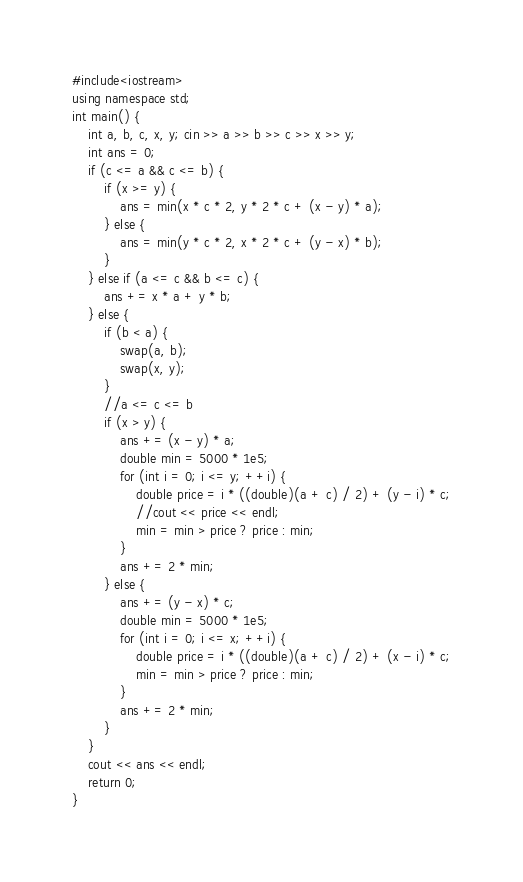<code> <loc_0><loc_0><loc_500><loc_500><_C++_>#include<iostream>
using namespace std;
int main() {
    int a, b, c, x, y; cin >> a >> b >> c >> x >> y;
    int ans = 0;
    if (c <= a && c <= b) {
        if (x >= y) {
            ans = min(x * c * 2, y * 2 * c + (x - y) * a);
        } else {
            ans = min(y * c * 2, x * 2 * c + (y - x) * b);
        }
    } else if (a <= c && b <= c) {
        ans += x * a + y * b;
    } else {
        if (b < a) {
            swap(a, b);
            swap(x, y);
        }
        //a <= c <= b
        if (x > y) {
            ans += (x - y) * a;
            double min = 5000 * 1e5;
            for (int i = 0; i <= y; ++i) {
                double price = i * ((double)(a + c) / 2) + (y - i) * c;
                //cout << price << endl;
                min = min > price ? price : min;
            }
            ans += 2 * min;
        } else {
            ans += (y - x) * c;
            double min = 5000 * 1e5;
            for (int i = 0; i <= x; ++i) {
                double price = i * ((double)(a + c) / 2) + (x - i) * c;
                min = min > price ? price : min;
            }
            ans += 2 * min;
        }
    }
    cout << ans << endl;
    return 0;
}


</code> 